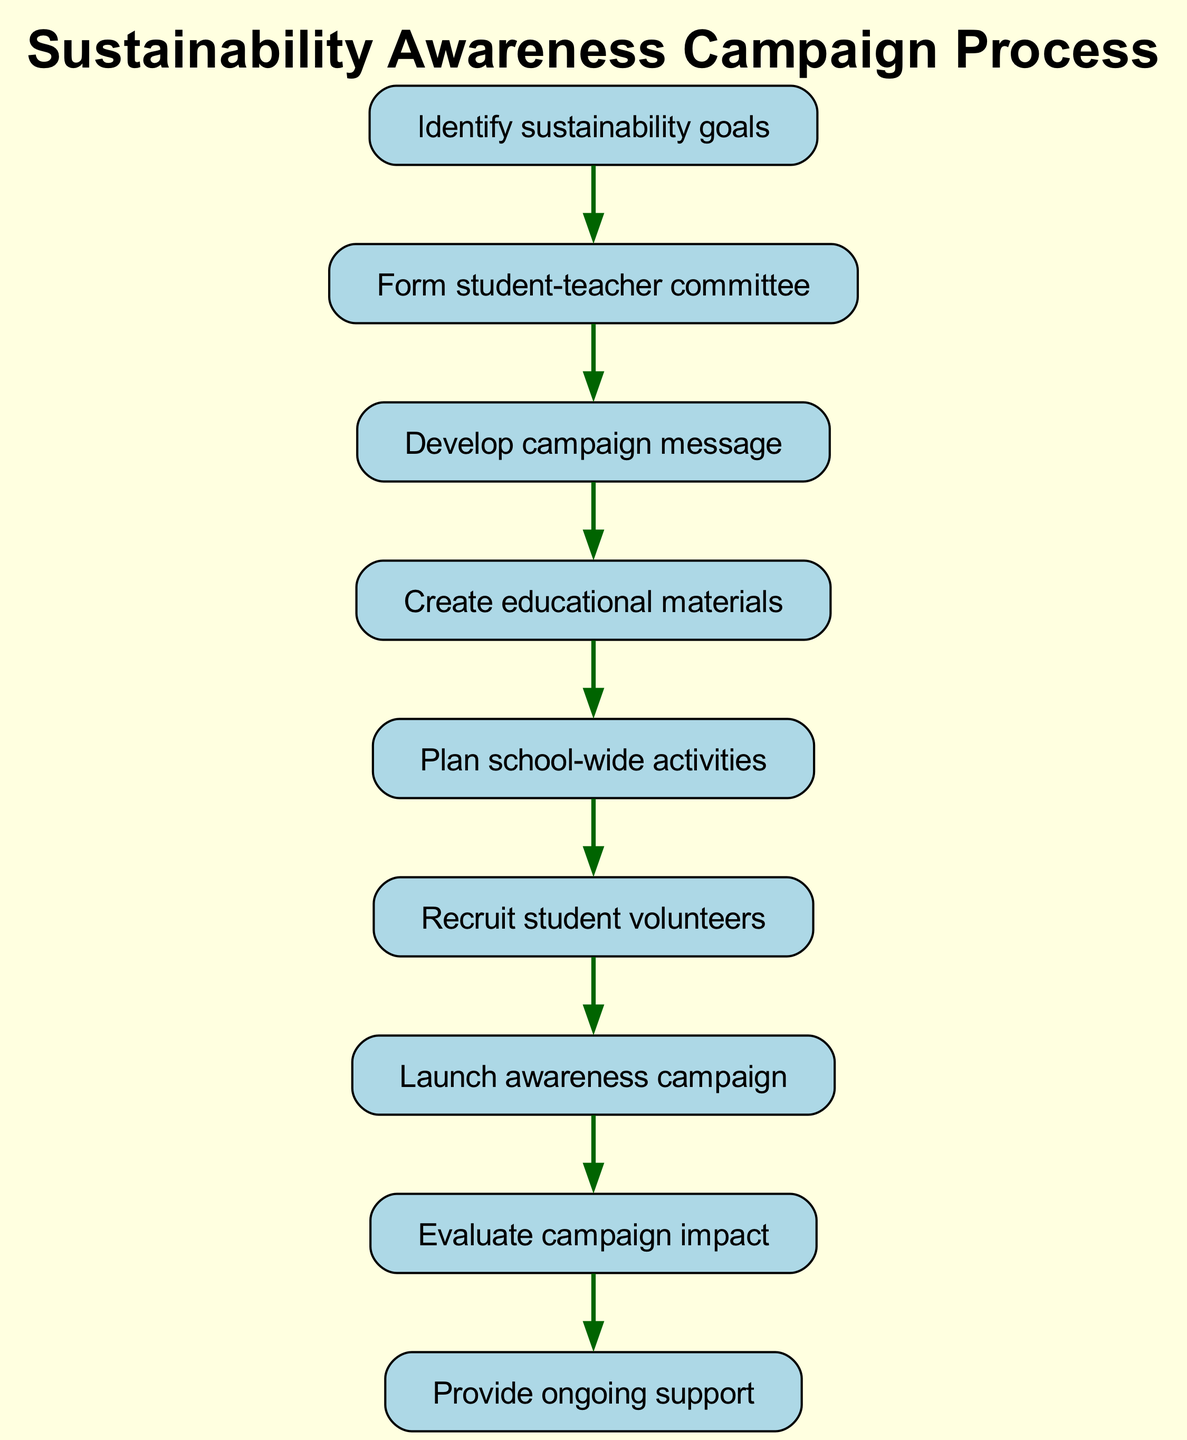What is the first step in the process? The first step is identified by the first node in the diagram, which states "Identify sustainability goals". This is the starting point before any other actions can take place.
Answer: Identify sustainability goals How many total nodes are there in the diagram? Counting all the nodes listed in the diagram, we find a total of 9 different steps from "Identify sustainability goals" to "Provide ongoing support".
Answer: 9 What step follows the development of the campaign message? The next step after developing the campaign message is indicated in the arrow leading from "Develop campaign message" to "Create educational materials". Thus, they are directly connected.
Answer: Create educational materials Which step has no subsequent action? The final step is "Provide ongoing support", which does not lead to any further action, making it the terminal node in the flow.
Answer: Provide ongoing support What is the last action taken in the campaign process? The last action can be determined by tracing the final node, which shows that "Evaluate campaign impact" leads to "Provide ongoing support", indicating that evaluating comes just before the ongoing support.
Answer: Evaluate campaign impact Which nodes are directly connected to the node "Plan school-wide activities"? The node "Plan school-wide activities" connects to two nodes: "Create educational materials" before it and "Recruit student volunteers" after it. This shows the flow of actions surrounding this specific step.
Answer: Create educational materials, Recruit student volunteers What is the relationship between the steps "Recruit student volunteers" and "Launch awareness campaign"? The relationship shows a direct progression from "Recruit student volunteers" leading directly to "Launch awareness campaign", indicating that volunteer recruitment is essential before launching the campaign.
Answer: Direct progression Which node appears just before the "Launch awareness campaign"? Tracing back in the flow chart, the step that comes just before the "Launch awareness campaign" is "Recruit student volunteers". Thus, it's the preceding step leading up to the campaign's launch.
Answer: Recruit student volunteers 